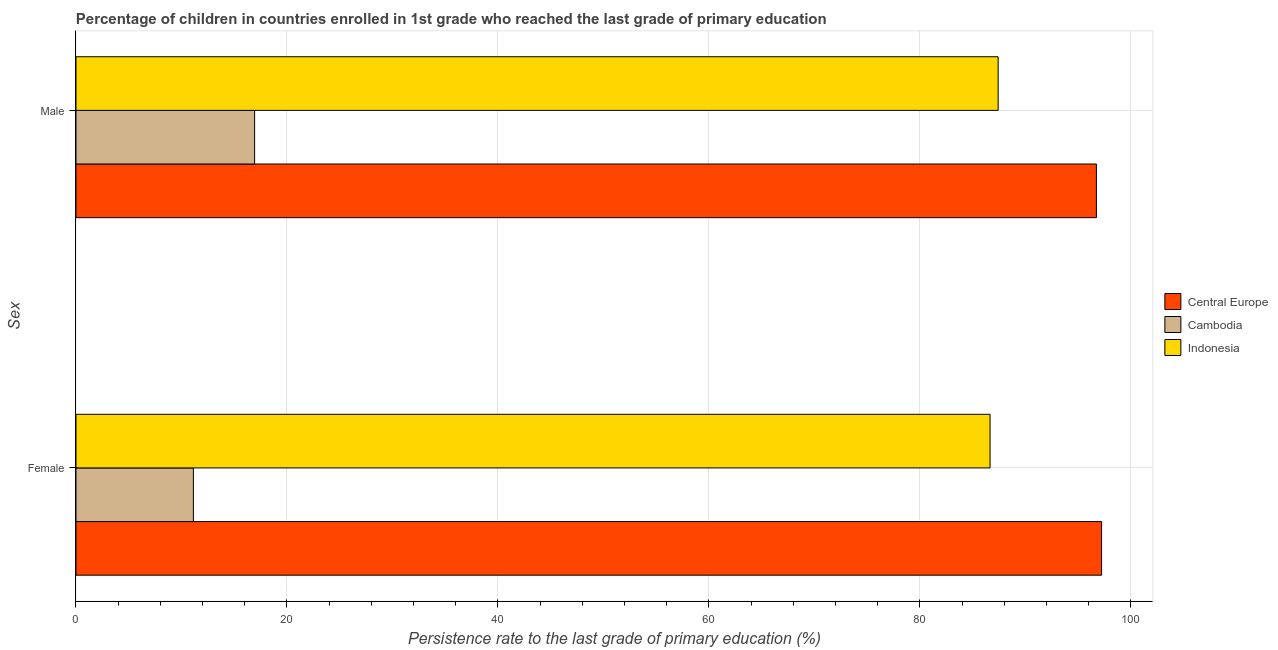Are the number of bars per tick equal to the number of legend labels?
Your answer should be very brief. Yes. What is the persistence rate of female students in Central Europe?
Provide a succinct answer. 97.23. Across all countries, what is the maximum persistence rate of female students?
Your answer should be compact. 97.23. Across all countries, what is the minimum persistence rate of female students?
Your answer should be very brief. 11.13. In which country was the persistence rate of male students maximum?
Your answer should be compact. Central Europe. In which country was the persistence rate of male students minimum?
Give a very brief answer. Cambodia. What is the total persistence rate of male students in the graph?
Make the answer very short. 201.1. What is the difference between the persistence rate of male students in Central Europe and that in Cambodia?
Give a very brief answer. 79.81. What is the difference between the persistence rate of female students in Indonesia and the persistence rate of male students in Central Europe?
Offer a terse response. -10.08. What is the average persistence rate of female students per country?
Make the answer very short. 65. What is the difference between the persistence rate of male students and persistence rate of female students in Cambodia?
Your response must be concise. 5.8. What is the ratio of the persistence rate of female students in Indonesia to that in Cambodia?
Your answer should be very brief. 7.79. In how many countries, is the persistence rate of female students greater than the average persistence rate of female students taken over all countries?
Keep it short and to the point. 2. What does the 2nd bar from the top in Male represents?
Your response must be concise. Cambodia. How many bars are there?
Offer a terse response. 6. Are all the bars in the graph horizontal?
Offer a very short reply. Yes. How many countries are there in the graph?
Your answer should be very brief. 3. What is the difference between two consecutive major ticks on the X-axis?
Ensure brevity in your answer.  20. Are the values on the major ticks of X-axis written in scientific E-notation?
Ensure brevity in your answer.  No. Where does the legend appear in the graph?
Make the answer very short. Center right. How many legend labels are there?
Make the answer very short. 3. What is the title of the graph?
Your response must be concise. Percentage of children in countries enrolled in 1st grade who reached the last grade of primary education. What is the label or title of the X-axis?
Provide a short and direct response. Persistence rate to the last grade of primary education (%). What is the label or title of the Y-axis?
Provide a succinct answer. Sex. What is the Persistence rate to the last grade of primary education (%) in Central Europe in Female?
Offer a terse response. 97.23. What is the Persistence rate to the last grade of primary education (%) of Cambodia in Female?
Provide a succinct answer. 11.13. What is the Persistence rate to the last grade of primary education (%) of Indonesia in Female?
Your response must be concise. 86.66. What is the Persistence rate to the last grade of primary education (%) in Central Europe in Male?
Offer a terse response. 96.74. What is the Persistence rate to the last grade of primary education (%) in Cambodia in Male?
Offer a very short reply. 16.93. What is the Persistence rate to the last grade of primary education (%) in Indonesia in Male?
Make the answer very short. 87.42. Across all Sex, what is the maximum Persistence rate to the last grade of primary education (%) of Central Europe?
Offer a very short reply. 97.23. Across all Sex, what is the maximum Persistence rate to the last grade of primary education (%) of Cambodia?
Ensure brevity in your answer.  16.93. Across all Sex, what is the maximum Persistence rate to the last grade of primary education (%) of Indonesia?
Ensure brevity in your answer.  87.42. Across all Sex, what is the minimum Persistence rate to the last grade of primary education (%) of Central Europe?
Provide a succinct answer. 96.74. Across all Sex, what is the minimum Persistence rate to the last grade of primary education (%) of Cambodia?
Keep it short and to the point. 11.13. Across all Sex, what is the minimum Persistence rate to the last grade of primary education (%) in Indonesia?
Offer a terse response. 86.66. What is the total Persistence rate to the last grade of primary education (%) in Central Europe in the graph?
Your answer should be very brief. 193.97. What is the total Persistence rate to the last grade of primary education (%) in Cambodia in the graph?
Give a very brief answer. 28.06. What is the total Persistence rate to the last grade of primary education (%) of Indonesia in the graph?
Offer a very short reply. 174.08. What is the difference between the Persistence rate to the last grade of primary education (%) in Central Europe in Female and that in Male?
Make the answer very short. 0.49. What is the difference between the Persistence rate to the last grade of primary education (%) in Cambodia in Female and that in Male?
Your answer should be compact. -5.8. What is the difference between the Persistence rate to the last grade of primary education (%) of Indonesia in Female and that in Male?
Ensure brevity in your answer.  -0.77. What is the difference between the Persistence rate to the last grade of primary education (%) in Central Europe in Female and the Persistence rate to the last grade of primary education (%) in Cambodia in Male?
Your answer should be very brief. 80.29. What is the difference between the Persistence rate to the last grade of primary education (%) in Central Europe in Female and the Persistence rate to the last grade of primary education (%) in Indonesia in Male?
Your response must be concise. 9.81. What is the difference between the Persistence rate to the last grade of primary education (%) of Cambodia in Female and the Persistence rate to the last grade of primary education (%) of Indonesia in Male?
Give a very brief answer. -76.29. What is the average Persistence rate to the last grade of primary education (%) of Central Europe per Sex?
Your response must be concise. 96.98. What is the average Persistence rate to the last grade of primary education (%) in Cambodia per Sex?
Your response must be concise. 14.03. What is the average Persistence rate to the last grade of primary education (%) of Indonesia per Sex?
Offer a terse response. 87.04. What is the difference between the Persistence rate to the last grade of primary education (%) of Central Europe and Persistence rate to the last grade of primary education (%) of Cambodia in Female?
Your response must be concise. 86.1. What is the difference between the Persistence rate to the last grade of primary education (%) in Central Europe and Persistence rate to the last grade of primary education (%) in Indonesia in Female?
Make the answer very short. 10.57. What is the difference between the Persistence rate to the last grade of primary education (%) of Cambodia and Persistence rate to the last grade of primary education (%) of Indonesia in Female?
Your answer should be very brief. -75.53. What is the difference between the Persistence rate to the last grade of primary education (%) in Central Europe and Persistence rate to the last grade of primary education (%) in Cambodia in Male?
Your response must be concise. 79.81. What is the difference between the Persistence rate to the last grade of primary education (%) of Central Europe and Persistence rate to the last grade of primary education (%) of Indonesia in Male?
Offer a terse response. 9.32. What is the difference between the Persistence rate to the last grade of primary education (%) of Cambodia and Persistence rate to the last grade of primary education (%) of Indonesia in Male?
Provide a short and direct response. -70.49. What is the ratio of the Persistence rate to the last grade of primary education (%) in Cambodia in Female to that in Male?
Make the answer very short. 0.66. What is the difference between the highest and the second highest Persistence rate to the last grade of primary education (%) in Central Europe?
Provide a succinct answer. 0.49. What is the difference between the highest and the second highest Persistence rate to the last grade of primary education (%) in Cambodia?
Offer a very short reply. 5.8. What is the difference between the highest and the second highest Persistence rate to the last grade of primary education (%) of Indonesia?
Keep it short and to the point. 0.77. What is the difference between the highest and the lowest Persistence rate to the last grade of primary education (%) in Central Europe?
Offer a terse response. 0.49. What is the difference between the highest and the lowest Persistence rate to the last grade of primary education (%) in Cambodia?
Make the answer very short. 5.8. What is the difference between the highest and the lowest Persistence rate to the last grade of primary education (%) of Indonesia?
Your answer should be very brief. 0.77. 